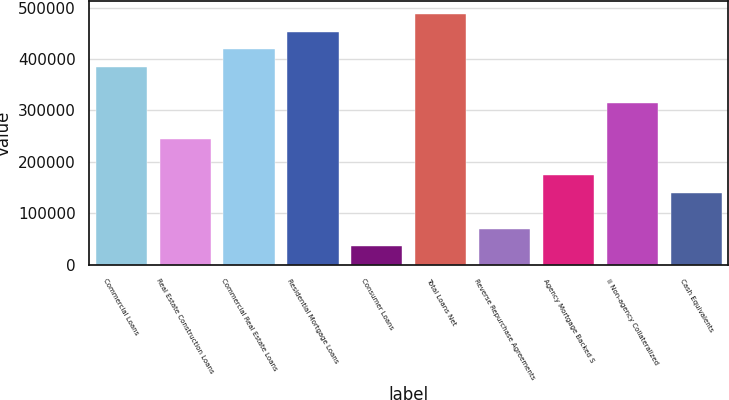Convert chart to OTSL. <chart><loc_0><loc_0><loc_500><loc_500><bar_chart><fcel>Commercial Loans<fcel>Real Estate Construction Loans<fcel>Commercial Real Estate Loans<fcel>Residential Mortgage Loans<fcel>Consumer Loans<fcel>Total Loans Net<fcel>Reverse Repurchase Agreements<fcel>Agency Mortgage Backed S<fcel>ii Non-agency Collateralized<fcel>Cash Equivalents<nl><fcel>383983<fcel>244491<fcel>418856<fcel>453729<fcel>35253.9<fcel>488602<fcel>70126.8<fcel>174746<fcel>314237<fcel>139873<nl></chart> 